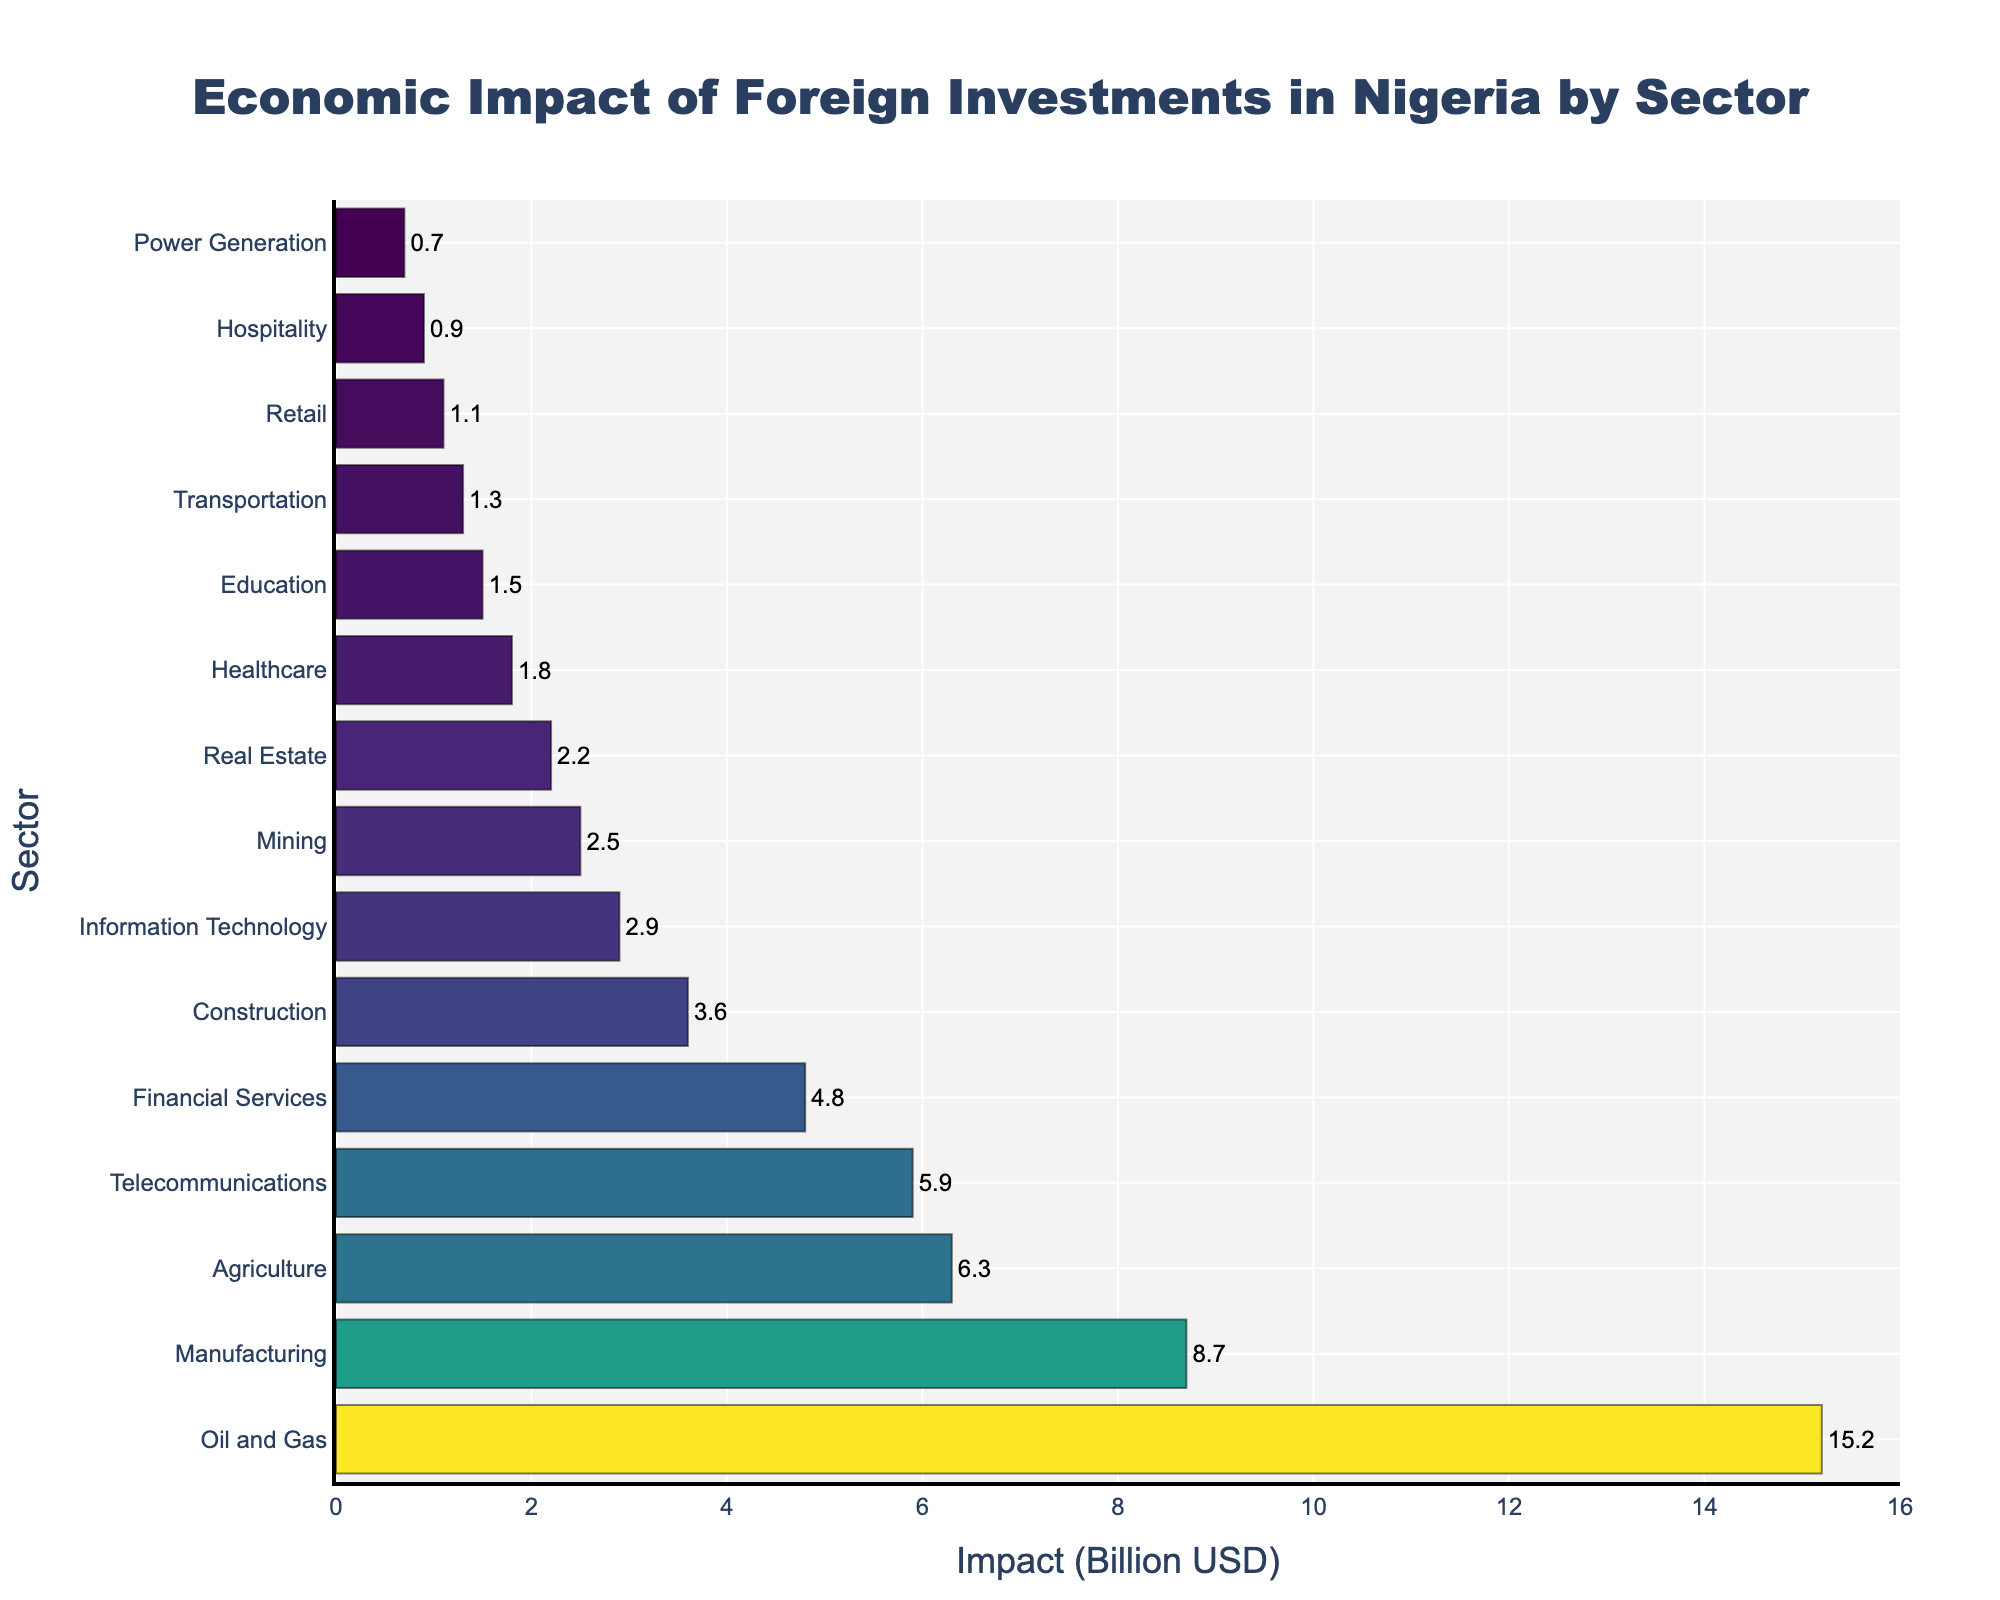Which sector has the highest economic impact from foreign investments? The sector with the highest economic impact is determined by the tallest bar on the chart. The oil and gas sector is at the top with an impact of 15.2 billion USD.
Answer: Oil and Gas What is the combined economic impact of the agriculture and telecommunications sectors? The values for agriculture and telecommunications are 6.3 billion USD and 5.9 billion USD, respectively. Adding these two gives 6.3 + 5.9 = 12.2 billion USD.
Answer: 12.2 billion USD Which sector has a greater economic impact: healthcare or education? By comparing the lengths of the bars, we see that healthcare has an economic impact of 1.8 billion USD, while education has 1.5 billion USD. Therefore, healthcare has a greater impact.
Answer: Healthcare What is the difference in economic impact between manufacturing and financial services? The economic impact for manufacturing is 8.7 billion USD and for financial services is 4.8 billion USD. The difference is 8.7 - 4.8 = 3.9 billion USD.
Answer: 3.9 billion USD How many sectors have an economic impact of more than 5 billion USD? By counting the number of bars that exceed 5 billion USD, we find that these sectors are oil and gas, manufacturing, agriculture, and telecommunications, totaling to 4 sectors.
Answer: 4 What is the average economic impact of the top 5 sectors? The top 5 sectors are oil and gas (15.2), manufacturing (8.7), agriculture (6.3), telecommunications (5.9), and financial services (4.8). The sum is 15.2 + 8.7 + 6.3 + 5.9 + 4.8 = 40.9. The average is 40.9 / 5 = 8.18 billion USD.
Answer: 8.18 billion USD Is the economic impact of the mining sector more or less than real estate? By comparing the bars, mining has an economic impact of 2.5 billion USD and real estate has 2.2 billion USD. Mining has a higher impact.
Answer: Mining Which sector has the smallest economic impact from foreign investments? The sector with the smallest bar, which is the power generation sector, has the smallest economic impact of 0.7 billion USD.
Answer: Power Generation What is the range of economic impacts among all sectors? The highest impact is 15.2 billion USD (oil and gas) and the lowest is 0.7 billion USD (power generation). The range is 15.2 - 0.7 = 14.5 billion USD.
Answer: 14.5 billion USD How does the economic impact of the construction sector visually compare to that of information technology? The bar for construction (3.6 billion USD) is slightly longer than the bar for information technology (2.9 billion USD).
Answer: Construction 